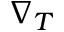<formula> <loc_0><loc_0><loc_500><loc_500>\nabla _ { T }</formula> 